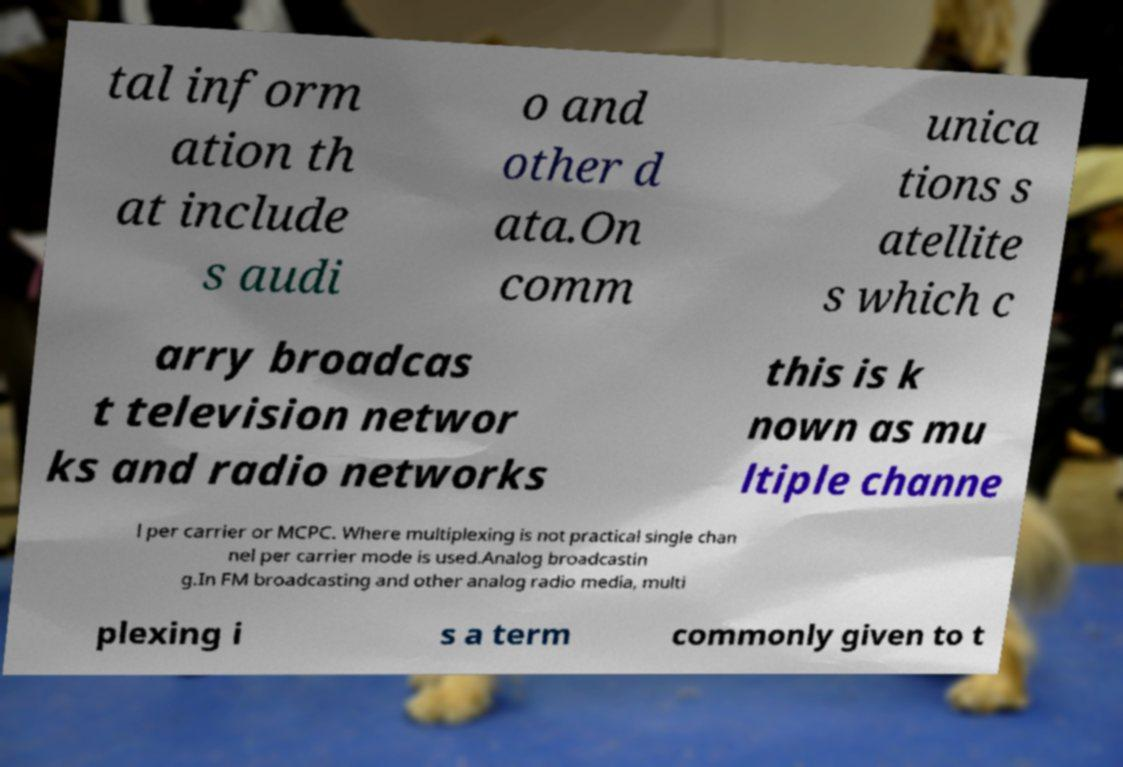Could you assist in decoding the text presented in this image and type it out clearly? tal inform ation th at include s audi o and other d ata.On comm unica tions s atellite s which c arry broadcas t television networ ks and radio networks this is k nown as mu ltiple channe l per carrier or MCPC. Where multiplexing is not practical single chan nel per carrier mode is used.Analog broadcastin g.In FM broadcasting and other analog radio media, multi plexing i s a term commonly given to t 